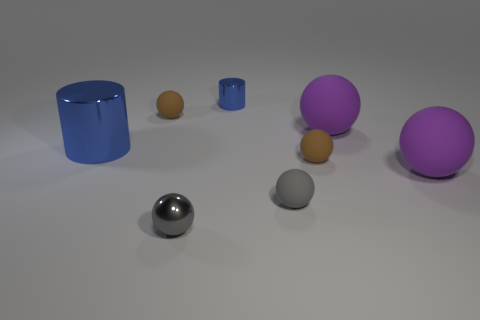The tiny object that is both on the right side of the metallic sphere and on the left side of the small gray rubber ball is made of what material?
Your response must be concise. Metal. What shape is the gray thing that is the same material as the big blue cylinder?
Your answer should be compact. Sphere. What size is the blue object that is made of the same material as the tiny cylinder?
Keep it short and to the point. Large. There is a object that is behind the big metal cylinder and left of the tiny shiny cylinder; what shape is it?
Your response must be concise. Sphere. What is the size of the blue shiny cylinder that is to the left of the small matte ball that is to the left of the small cylinder?
Give a very brief answer. Large. How many other objects are there of the same color as the small cylinder?
Give a very brief answer. 1. What is the material of the small blue object?
Provide a succinct answer. Metal. Are there any red metallic blocks?
Give a very brief answer. No. Is the number of rubber objects in front of the small blue metal thing the same as the number of rubber balls?
Keep it short and to the point. Yes. How many large things are either blue metallic cylinders or gray spheres?
Make the answer very short. 1. 